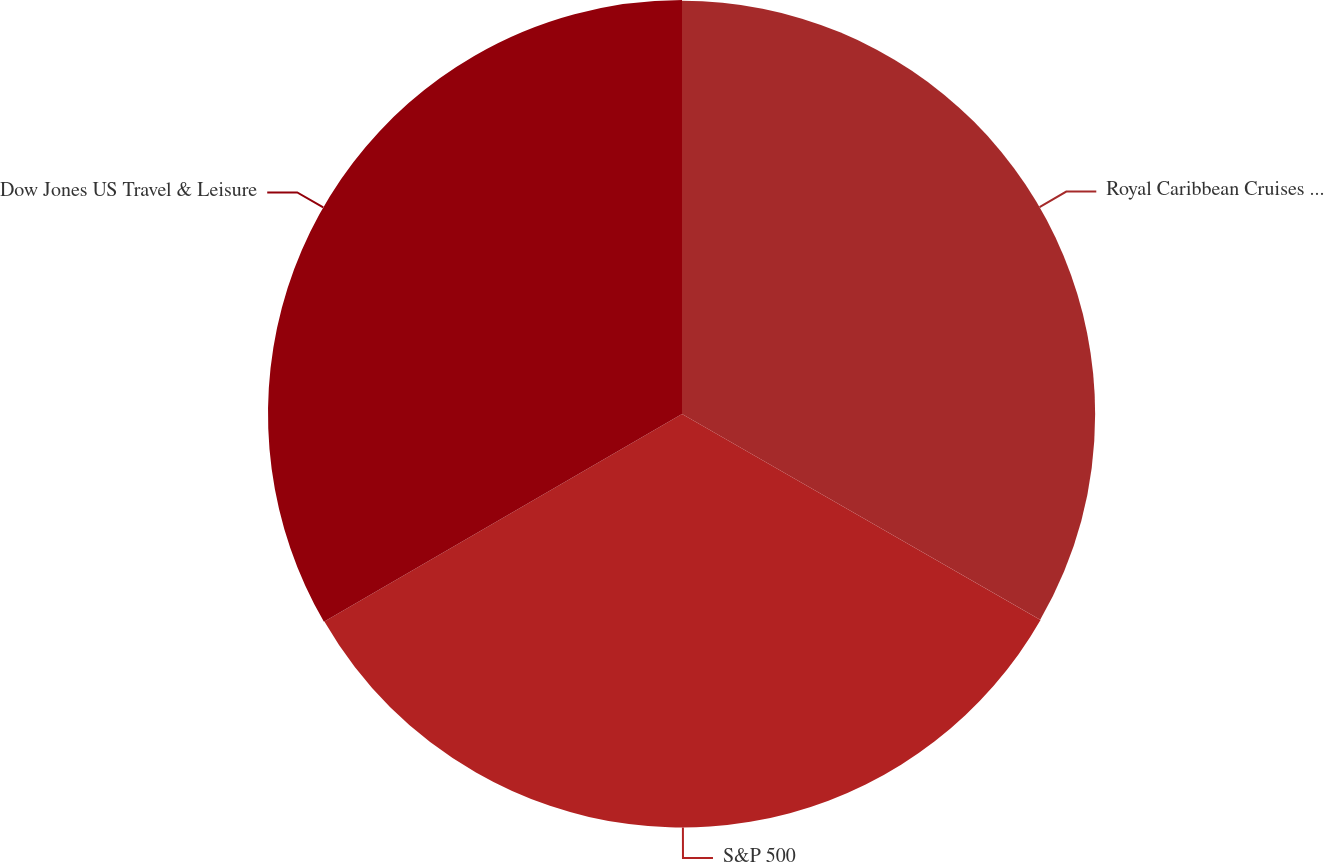Convert chart. <chart><loc_0><loc_0><loc_500><loc_500><pie_chart><fcel>Royal Caribbean Cruises Ltd<fcel>S&P 500<fcel>Dow Jones US Travel & Leisure<nl><fcel>33.3%<fcel>33.33%<fcel>33.37%<nl></chart> 